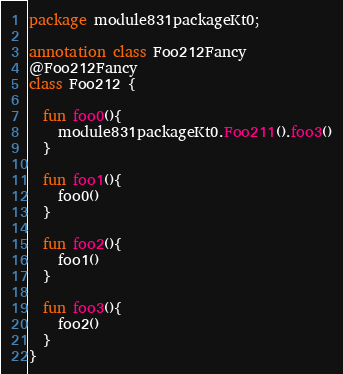Convert code to text. <code><loc_0><loc_0><loc_500><loc_500><_Kotlin_>package module831packageKt0;

annotation class Foo212Fancy
@Foo212Fancy
class Foo212 {

  fun foo0(){
    module831packageKt0.Foo211().foo3()
  }

  fun foo1(){
    foo0()
  }

  fun foo2(){
    foo1()
  }

  fun foo3(){
    foo2()
  }
}</code> 